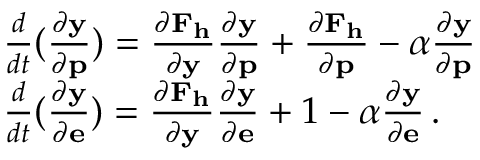<formula> <loc_0><loc_0><loc_500><loc_500>\begin{array} { r l } & { \frac { d } { d t } ( \frac { \partial y } { \partial p } ) = \frac { \partial F _ { h } } { \partial y } \frac { \partial y } { \partial p } + \frac { \partial F _ { h } } { \partial p } - \alpha \frac { \partial y } { \partial p } } \\ & { \frac { d } { d t } ( \frac { \partial y } { \partial e } ) = \frac { \partial F _ { h } } { \partial y } \frac { \partial y } { \partial e } + 1 - \alpha \frac { \partial y } { \partial e } \, . } \end{array}</formula> 